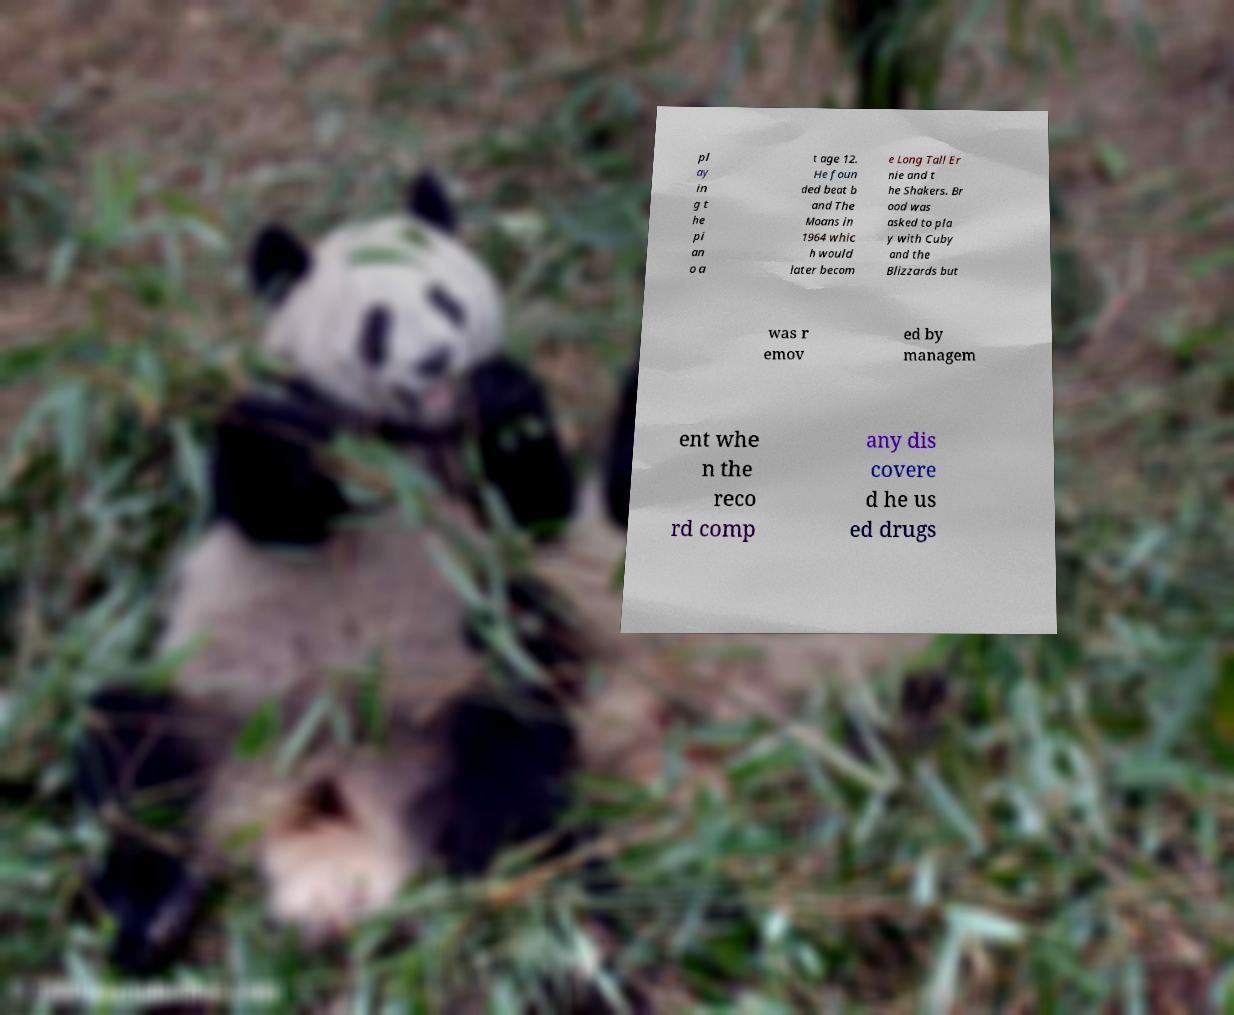Could you extract and type out the text from this image? pl ay in g t he pi an o a t age 12. He foun ded beat b and The Moans in 1964 whic h would later becom e Long Tall Er nie and t he Shakers. Br ood was asked to pla y with Cuby and the Blizzards but was r emov ed by managem ent whe n the reco rd comp any dis covere d he us ed drugs 